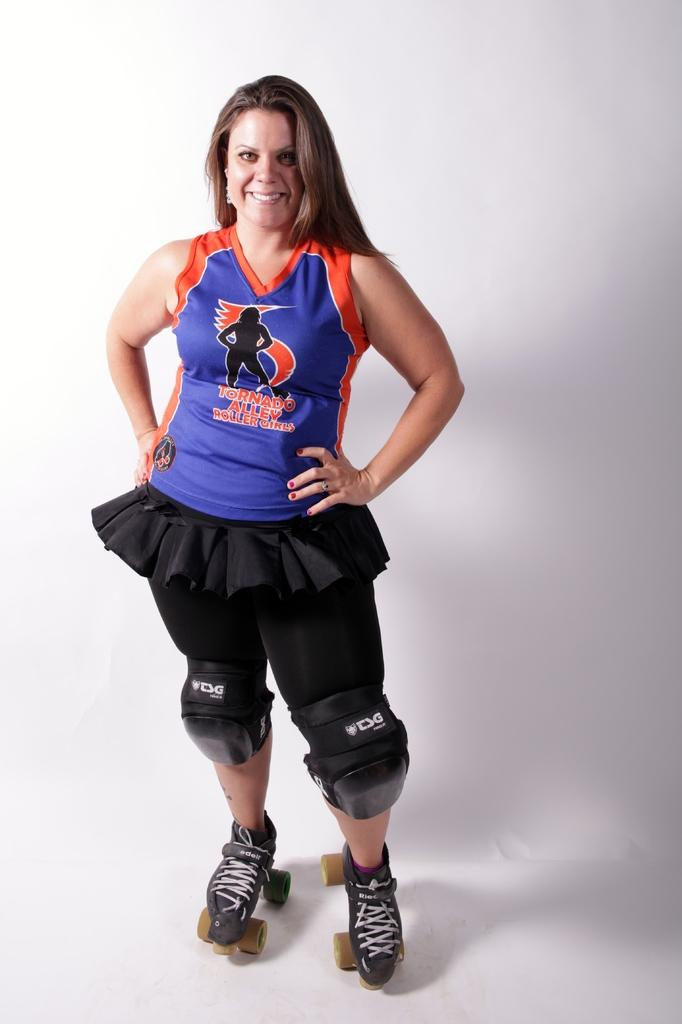<image>
Share a concise interpretation of the image provided. a woman on sports gear and rollerskates with Tornado alley roller girls on her shirt 